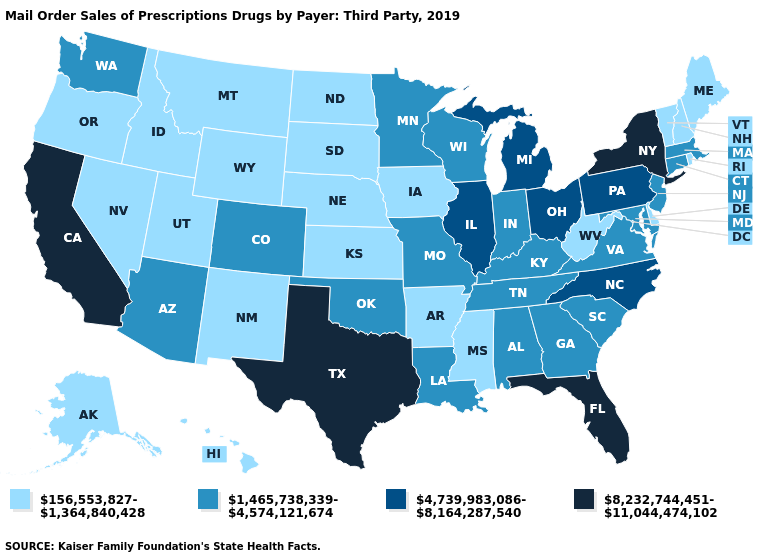Name the states that have a value in the range 156,553,827-1,364,840,428?
Give a very brief answer. Alaska, Arkansas, Delaware, Hawaii, Idaho, Iowa, Kansas, Maine, Mississippi, Montana, Nebraska, Nevada, New Hampshire, New Mexico, North Dakota, Oregon, Rhode Island, South Dakota, Utah, Vermont, West Virginia, Wyoming. Which states have the lowest value in the Northeast?
Keep it brief. Maine, New Hampshire, Rhode Island, Vermont. Name the states that have a value in the range 1,465,738,339-4,574,121,674?
Give a very brief answer. Alabama, Arizona, Colorado, Connecticut, Georgia, Indiana, Kentucky, Louisiana, Maryland, Massachusetts, Minnesota, Missouri, New Jersey, Oklahoma, South Carolina, Tennessee, Virginia, Washington, Wisconsin. Does Nevada have the highest value in the USA?
Keep it brief. No. Does Indiana have a lower value than Maine?
Keep it brief. No. What is the lowest value in states that border Kentucky?
Concise answer only. 156,553,827-1,364,840,428. Does Texas have the highest value in the USA?
Give a very brief answer. Yes. Does Hawaii have the highest value in the USA?
Concise answer only. No. Does Vermont have the highest value in the Northeast?
Keep it brief. No. Does Wyoming have a lower value than New Mexico?
Short answer required. No. Does the map have missing data?
Be succinct. No. What is the value of Ohio?
Give a very brief answer. 4,739,983,086-8,164,287,540. Name the states that have a value in the range 8,232,744,451-11,044,474,102?
Give a very brief answer. California, Florida, New York, Texas. What is the lowest value in the South?
Quick response, please. 156,553,827-1,364,840,428. Among the states that border Utah , which have the highest value?
Quick response, please. Arizona, Colorado. 